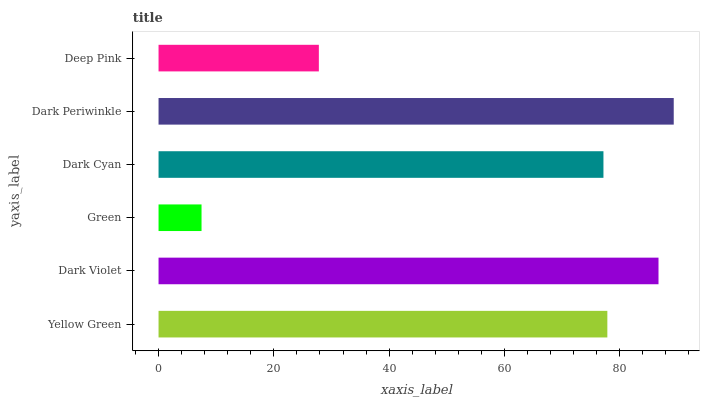Is Green the minimum?
Answer yes or no. Yes. Is Dark Periwinkle the maximum?
Answer yes or no. Yes. Is Dark Violet the minimum?
Answer yes or no. No. Is Dark Violet the maximum?
Answer yes or no. No. Is Dark Violet greater than Yellow Green?
Answer yes or no. Yes. Is Yellow Green less than Dark Violet?
Answer yes or no. Yes. Is Yellow Green greater than Dark Violet?
Answer yes or no. No. Is Dark Violet less than Yellow Green?
Answer yes or no. No. Is Yellow Green the high median?
Answer yes or no. Yes. Is Dark Cyan the low median?
Answer yes or no. Yes. Is Deep Pink the high median?
Answer yes or no. No. Is Green the low median?
Answer yes or no. No. 